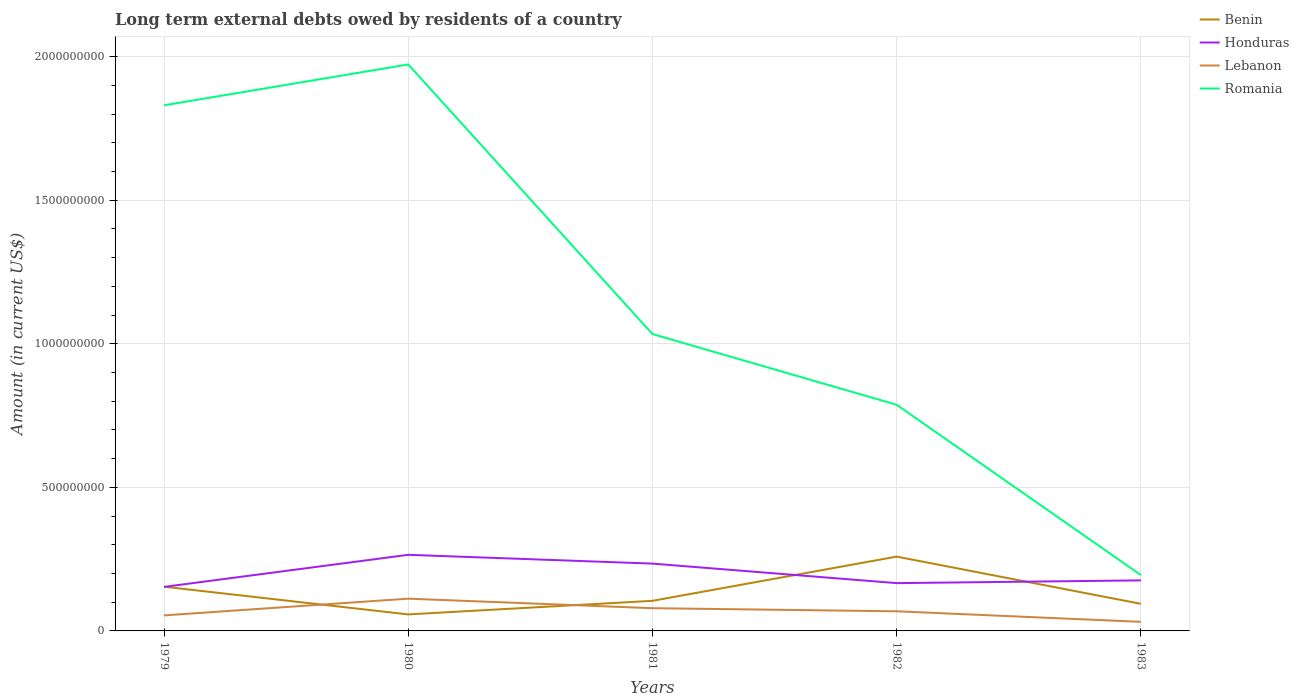How many different coloured lines are there?
Offer a terse response. 4. Across all years, what is the maximum amount of long-term external debts owed by residents in Benin?
Your answer should be very brief. 5.75e+07. In which year was the amount of long-term external debts owed by residents in Romania maximum?
Your response must be concise. 1983. What is the total amount of long-term external debts owed by residents in Honduras in the graph?
Give a very brief answer. -1.31e+07. What is the difference between the highest and the second highest amount of long-term external debts owed by residents in Lebanon?
Give a very brief answer. 8.07e+07. What is the difference between the highest and the lowest amount of long-term external debts owed by residents in Honduras?
Ensure brevity in your answer.  2. Is the amount of long-term external debts owed by residents in Romania strictly greater than the amount of long-term external debts owed by residents in Honduras over the years?
Keep it short and to the point. No. How many years are there in the graph?
Your answer should be compact. 5. Does the graph contain any zero values?
Provide a short and direct response. No. What is the title of the graph?
Ensure brevity in your answer.  Long term external debts owed by residents of a country. What is the label or title of the X-axis?
Give a very brief answer. Years. What is the label or title of the Y-axis?
Provide a succinct answer. Amount (in current US$). What is the Amount (in current US$) of Benin in 1979?
Offer a terse response. 1.54e+08. What is the Amount (in current US$) of Honduras in 1979?
Provide a succinct answer. 1.53e+08. What is the Amount (in current US$) of Lebanon in 1979?
Make the answer very short. 5.41e+07. What is the Amount (in current US$) in Romania in 1979?
Give a very brief answer. 1.83e+09. What is the Amount (in current US$) in Benin in 1980?
Give a very brief answer. 5.75e+07. What is the Amount (in current US$) in Honduras in 1980?
Your answer should be very brief. 2.65e+08. What is the Amount (in current US$) of Lebanon in 1980?
Ensure brevity in your answer.  1.12e+08. What is the Amount (in current US$) of Romania in 1980?
Offer a very short reply. 1.97e+09. What is the Amount (in current US$) in Benin in 1981?
Your answer should be compact. 1.05e+08. What is the Amount (in current US$) of Honduras in 1981?
Offer a very short reply. 2.34e+08. What is the Amount (in current US$) of Lebanon in 1981?
Your answer should be compact. 7.92e+07. What is the Amount (in current US$) in Romania in 1981?
Keep it short and to the point. 1.03e+09. What is the Amount (in current US$) in Benin in 1982?
Give a very brief answer. 2.59e+08. What is the Amount (in current US$) in Honduras in 1982?
Provide a short and direct response. 1.66e+08. What is the Amount (in current US$) in Lebanon in 1982?
Your response must be concise. 6.84e+07. What is the Amount (in current US$) of Romania in 1982?
Keep it short and to the point. 7.88e+08. What is the Amount (in current US$) of Benin in 1983?
Offer a very short reply. 9.44e+07. What is the Amount (in current US$) in Honduras in 1983?
Offer a terse response. 1.76e+08. What is the Amount (in current US$) of Lebanon in 1983?
Offer a terse response. 3.17e+07. What is the Amount (in current US$) of Romania in 1983?
Your answer should be very brief. 1.95e+08. Across all years, what is the maximum Amount (in current US$) of Benin?
Give a very brief answer. 2.59e+08. Across all years, what is the maximum Amount (in current US$) of Honduras?
Keep it short and to the point. 2.65e+08. Across all years, what is the maximum Amount (in current US$) in Lebanon?
Provide a short and direct response. 1.12e+08. Across all years, what is the maximum Amount (in current US$) in Romania?
Give a very brief answer. 1.97e+09. Across all years, what is the minimum Amount (in current US$) in Benin?
Your answer should be very brief. 5.75e+07. Across all years, what is the minimum Amount (in current US$) in Honduras?
Provide a short and direct response. 1.53e+08. Across all years, what is the minimum Amount (in current US$) in Lebanon?
Your answer should be compact. 3.17e+07. Across all years, what is the minimum Amount (in current US$) of Romania?
Offer a very short reply. 1.95e+08. What is the total Amount (in current US$) of Benin in the graph?
Give a very brief answer. 6.70e+08. What is the total Amount (in current US$) of Honduras in the graph?
Provide a short and direct response. 9.95e+08. What is the total Amount (in current US$) in Lebanon in the graph?
Offer a very short reply. 3.46e+08. What is the total Amount (in current US$) in Romania in the graph?
Your answer should be compact. 5.82e+09. What is the difference between the Amount (in current US$) in Benin in 1979 and that in 1980?
Provide a succinct answer. 9.65e+07. What is the difference between the Amount (in current US$) in Honduras in 1979 and that in 1980?
Your response must be concise. -1.12e+08. What is the difference between the Amount (in current US$) in Lebanon in 1979 and that in 1980?
Give a very brief answer. -5.83e+07. What is the difference between the Amount (in current US$) of Romania in 1979 and that in 1980?
Your response must be concise. -1.42e+08. What is the difference between the Amount (in current US$) of Benin in 1979 and that in 1981?
Ensure brevity in your answer.  4.92e+07. What is the difference between the Amount (in current US$) of Honduras in 1979 and that in 1981?
Offer a terse response. -8.11e+07. What is the difference between the Amount (in current US$) of Lebanon in 1979 and that in 1981?
Offer a terse response. -2.51e+07. What is the difference between the Amount (in current US$) in Romania in 1979 and that in 1981?
Your response must be concise. 7.97e+08. What is the difference between the Amount (in current US$) in Benin in 1979 and that in 1982?
Ensure brevity in your answer.  -1.05e+08. What is the difference between the Amount (in current US$) of Honduras in 1979 and that in 1982?
Your answer should be very brief. -1.31e+07. What is the difference between the Amount (in current US$) in Lebanon in 1979 and that in 1982?
Your response must be concise. -1.43e+07. What is the difference between the Amount (in current US$) in Romania in 1979 and that in 1982?
Provide a succinct answer. 1.04e+09. What is the difference between the Amount (in current US$) in Benin in 1979 and that in 1983?
Your answer should be compact. 5.96e+07. What is the difference between the Amount (in current US$) in Honduras in 1979 and that in 1983?
Offer a very short reply. -2.27e+07. What is the difference between the Amount (in current US$) of Lebanon in 1979 and that in 1983?
Ensure brevity in your answer.  2.24e+07. What is the difference between the Amount (in current US$) in Romania in 1979 and that in 1983?
Your answer should be compact. 1.64e+09. What is the difference between the Amount (in current US$) in Benin in 1980 and that in 1981?
Provide a succinct answer. -4.73e+07. What is the difference between the Amount (in current US$) of Honduras in 1980 and that in 1981?
Make the answer very short. 3.06e+07. What is the difference between the Amount (in current US$) of Lebanon in 1980 and that in 1981?
Provide a short and direct response. 3.32e+07. What is the difference between the Amount (in current US$) in Romania in 1980 and that in 1981?
Provide a short and direct response. 9.39e+08. What is the difference between the Amount (in current US$) in Benin in 1980 and that in 1982?
Keep it short and to the point. -2.01e+08. What is the difference between the Amount (in current US$) in Honduras in 1980 and that in 1982?
Offer a very short reply. 9.86e+07. What is the difference between the Amount (in current US$) in Lebanon in 1980 and that in 1982?
Provide a succinct answer. 4.40e+07. What is the difference between the Amount (in current US$) in Romania in 1980 and that in 1982?
Offer a terse response. 1.19e+09. What is the difference between the Amount (in current US$) in Benin in 1980 and that in 1983?
Offer a very short reply. -3.69e+07. What is the difference between the Amount (in current US$) in Honduras in 1980 and that in 1983?
Offer a very short reply. 8.90e+07. What is the difference between the Amount (in current US$) of Lebanon in 1980 and that in 1983?
Ensure brevity in your answer.  8.07e+07. What is the difference between the Amount (in current US$) of Romania in 1980 and that in 1983?
Keep it short and to the point. 1.78e+09. What is the difference between the Amount (in current US$) of Benin in 1981 and that in 1982?
Your response must be concise. -1.54e+08. What is the difference between the Amount (in current US$) of Honduras in 1981 and that in 1982?
Offer a very short reply. 6.80e+07. What is the difference between the Amount (in current US$) in Lebanon in 1981 and that in 1982?
Offer a terse response. 1.08e+07. What is the difference between the Amount (in current US$) of Romania in 1981 and that in 1982?
Make the answer very short. 2.46e+08. What is the difference between the Amount (in current US$) in Benin in 1981 and that in 1983?
Make the answer very short. 1.04e+07. What is the difference between the Amount (in current US$) of Honduras in 1981 and that in 1983?
Ensure brevity in your answer.  5.84e+07. What is the difference between the Amount (in current US$) in Lebanon in 1981 and that in 1983?
Make the answer very short. 4.75e+07. What is the difference between the Amount (in current US$) of Romania in 1981 and that in 1983?
Your answer should be very brief. 8.39e+08. What is the difference between the Amount (in current US$) in Benin in 1982 and that in 1983?
Your answer should be very brief. 1.64e+08. What is the difference between the Amount (in current US$) in Honduras in 1982 and that in 1983?
Provide a short and direct response. -9.57e+06. What is the difference between the Amount (in current US$) in Lebanon in 1982 and that in 1983?
Your answer should be very brief. 3.67e+07. What is the difference between the Amount (in current US$) in Romania in 1982 and that in 1983?
Provide a short and direct response. 5.93e+08. What is the difference between the Amount (in current US$) in Benin in 1979 and the Amount (in current US$) in Honduras in 1980?
Provide a short and direct response. -1.11e+08. What is the difference between the Amount (in current US$) of Benin in 1979 and the Amount (in current US$) of Lebanon in 1980?
Your answer should be very brief. 4.16e+07. What is the difference between the Amount (in current US$) in Benin in 1979 and the Amount (in current US$) in Romania in 1980?
Provide a short and direct response. -1.82e+09. What is the difference between the Amount (in current US$) in Honduras in 1979 and the Amount (in current US$) in Lebanon in 1980?
Offer a terse response. 4.10e+07. What is the difference between the Amount (in current US$) in Honduras in 1979 and the Amount (in current US$) in Romania in 1980?
Make the answer very short. -1.82e+09. What is the difference between the Amount (in current US$) of Lebanon in 1979 and the Amount (in current US$) of Romania in 1980?
Your response must be concise. -1.92e+09. What is the difference between the Amount (in current US$) in Benin in 1979 and the Amount (in current US$) in Honduras in 1981?
Offer a terse response. -8.04e+07. What is the difference between the Amount (in current US$) in Benin in 1979 and the Amount (in current US$) in Lebanon in 1981?
Your response must be concise. 7.49e+07. What is the difference between the Amount (in current US$) of Benin in 1979 and the Amount (in current US$) of Romania in 1981?
Keep it short and to the point. -8.80e+08. What is the difference between the Amount (in current US$) in Honduras in 1979 and the Amount (in current US$) in Lebanon in 1981?
Your answer should be compact. 7.42e+07. What is the difference between the Amount (in current US$) of Honduras in 1979 and the Amount (in current US$) of Romania in 1981?
Make the answer very short. -8.81e+08. What is the difference between the Amount (in current US$) in Lebanon in 1979 and the Amount (in current US$) in Romania in 1981?
Ensure brevity in your answer.  -9.80e+08. What is the difference between the Amount (in current US$) in Benin in 1979 and the Amount (in current US$) in Honduras in 1982?
Offer a terse response. -1.25e+07. What is the difference between the Amount (in current US$) in Benin in 1979 and the Amount (in current US$) in Lebanon in 1982?
Ensure brevity in your answer.  8.56e+07. What is the difference between the Amount (in current US$) in Benin in 1979 and the Amount (in current US$) in Romania in 1982?
Offer a terse response. -6.34e+08. What is the difference between the Amount (in current US$) of Honduras in 1979 and the Amount (in current US$) of Lebanon in 1982?
Ensure brevity in your answer.  8.50e+07. What is the difference between the Amount (in current US$) of Honduras in 1979 and the Amount (in current US$) of Romania in 1982?
Make the answer very short. -6.34e+08. What is the difference between the Amount (in current US$) of Lebanon in 1979 and the Amount (in current US$) of Romania in 1982?
Give a very brief answer. -7.34e+08. What is the difference between the Amount (in current US$) of Benin in 1979 and the Amount (in current US$) of Honduras in 1983?
Provide a succinct answer. -2.20e+07. What is the difference between the Amount (in current US$) of Benin in 1979 and the Amount (in current US$) of Lebanon in 1983?
Make the answer very short. 1.22e+08. What is the difference between the Amount (in current US$) of Benin in 1979 and the Amount (in current US$) of Romania in 1983?
Offer a very short reply. -4.06e+07. What is the difference between the Amount (in current US$) in Honduras in 1979 and the Amount (in current US$) in Lebanon in 1983?
Your answer should be compact. 1.22e+08. What is the difference between the Amount (in current US$) in Honduras in 1979 and the Amount (in current US$) in Romania in 1983?
Offer a very short reply. -4.12e+07. What is the difference between the Amount (in current US$) in Lebanon in 1979 and the Amount (in current US$) in Romania in 1983?
Keep it short and to the point. -1.40e+08. What is the difference between the Amount (in current US$) in Benin in 1980 and the Amount (in current US$) in Honduras in 1981?
Keep it short and to the point. -1.77e+08. What is the difference between the Amount (in current US$) of Benin in 1980 and the Amount (in current US$) of Lebanon in 1981?
Offer a terse response. -2.17e+07. What is the difference between the Amount (in current US$) in Benin in 1980 and the Amount (in current US$) in Romania in 1981?
Give a very brief answer. -9.76e+08. What is the difference between the Amount (in current US$) of Honduras in 1980 and the Amount (in current US$) of Lebanon in 1981?
Make the answer very short. 1.86e+08. What is the difference between the Amount (in current US$) of Honduras in 1980 and the Amount (in current US$) of Romania in 1981?
Your response must be concise. -7.69e+08. What is the difference between the Amount (in current US$) of Lebanon in 1980 and the Amount (in current US$) of Romania in 1981?
Your response must be concise. -9.22e+08. What is the difference between the Amount (in current US$) of Benin in 1980 and the Amount (in current US$) of Honduras in 1982?
Offer a very short reply. -1.09e+08. What is the difference between the Amount (in current US$) in Benin in 1980 and the Amount (in current US$) in Lebanon in 1982?
Provide a succinct answer. -1.09e+07. What is the difference between the Amount (in current US$) of Benin in 1980 and the Amount (in current US$) of Romania in 1982?
Offer a terse response. -7.30e+08. What is the difference between the Amount (in current US$) in Honduras in 1980 and the Amount (in current US$) in Lebanon in 1982?
Make the answer very short. 1.97e+08. What is the difference between the Amount (in current US$) in Honduras in 1980 and the Amount (in current US$) in Romania in 1982?
Provide a short and direct response. -5.23e+08. What is the difference between the Amount (in current US$) in Lebanon in 1980 and the Amount (in current US$) in Romania in 1982?
Your response must be concise. -6.75e+08. What is the difference between the Amount (in current US$) in Benin in 1980 and the Amount (in current US$) in Honduras in 1983?
Keep it short and to the point. -1.19e+08. What is the difference between the Amount (in current US$) of Benin in 1980 and the Amount (in current US$) of Lebanon in 1983?
Offer a terse response. 2.58e+07. What is the difference between the Amount (in current US$) of Benin in 1980 and the Amount (in current US$) of Romania in 1983?
Give a very brief answer. -1.37e+08. What is the difference between the Amount (in current US$) in Honduras in 1980 and the Amount (in current US$) in Lebanon in 1983?
Your answer should be compact. 2.33e+08. What is the difference between the Amount (in current US$) of Honduras in 1980 and the Amount (in current US$) of Romania in 1983?
Provide a succinct answer. 7.05e+07. What is the difference between the Amount (in current US$) in Lebanon in 1980 and the Amount (in current US$) in Romania in 1983?
Provide a succinct answer. -8.22e+07. What is the difference between the Amount (in current US$) of Benin in 1981 and the Amount (in current US$) of Honduras in 1982?
Offer a terse response. -6.17e+07. What is the difference between the Amount (in current US$) in Benin in 1981 and the Amount (in current US$) in Lebanon in 1982?
Your answer should be very brief. 3.64e+07. What is the difference between the Amount (in current US$) in Benin in 1981 and the Amount (in current US$) in Romania in 1982?
Ensure brevity in your answer.  -6.83e+08. What is the difference between the Amount (in current US$) in Honduras in 1981 and the Amount (in current US$) in Lebanon in 1982?
Provide a succinct answer. 1.66e+08. What is the difference between the Amount (in current US$) of Honduras in 1981 and the Amount (in current US$) of Romania in 1982?
Offer a very short reply. -5.53e+08. What is the difference between the Amount (in current US$) of Lebanon in 1981 and the Amount (in current US$) of Romania in 1982?
Your response must be concise. -7.08e+08. What is the difference between the Amount (in current US$) in Benin in 1981 and the Amount (in current US$) in Honduras in 1983?
Your answer should be compact. -7.12e+07. What is the difference between the Amount (in current US$) of Benin in 1981 and the Amount (in current US$) of Lebanon in 1983?
Your answer should be very brief. 7.31e+07. What is the difference between the Amount (in current US$) in Benin in 1981 and the Amount (in current US$) in Romania in 1983?
Offer a very short reply. -8.98e+07. What is the difference between the Amount (in current US$) of Honduras in 1981 and the Amount (in current US$) of Lebanon in 1983?
Make the answer very short. 2.03e+08. What is the difference between the Amount (in current US$) in Honduras in 1981 and the Amount (in current US$) in Romania in 1983?
Make the answer very short. 3.99e+07. What is the difference between the Amount (in current US$) of Lebanon in 1981 and the Amount (in current US$) of Romania in 1983?
Ensure brevity in your answer.  -1.15e+08. What is the difference between the Amount (in current US$) of Benin in 1982 and the Amount (in current US$) of Honduras in 1983?
Offer a very short reply. 8.28e+07. What is the difference between the Amount (in current US$) of Benin in 1982 and the Amount (in current US$) of Lebanon in 1983?
Offer a very short reply. 2.27e+08. What is the difference between the Amount (in current US$) in Benin in 1982 and the Amount (in current US$) in Romania in 1983?
Make the answer very short. 6.42e+07. What is the difference between the Amount (in current US$) in Honduras in 1982 and the Amount (in current US$) in Lebanon in 1983?
Keep it short and to the point. 1.35e+08. What is the difference between the Amount (in current US$) of Honduras in 1982 and the Amount (in current US$) of Romania in 1983?
Ensure brevity in your answer.  -2.81e+07. What is the difference between the Amount (in current US$) of Lebanon in 1982 and the Amount (in current US$) of Romania in 1983?
Ensure brevity in your answer.  -1.26e+08. What is the average Amount (in current US$) of Benin per year?
Provide a succinct answer. 1.34e+08. What is the average Amount (in current US$) in Honduras per year?
Offer a very short reply. 1.99e+08. What is the average Amount (in current US$) in Lebanon per year?
Ensure brevity in your answer.  6.91e+07. What is the average Amount (in current US$) in Romania per year?
Ensure brevity in your answer.  1.16e+09. In the year 1979, what is the difference between the Amount (in current US$) in Benin and Amount (in current US$) in Honduras?
Give a very brief answer. 6.81e+05. In the year 1979, what is the difference between the Amount (in current US$) of Benin and Amount (in current US$) of Lebanon?
Your answer should be compact. 9.99e+07. In the year 1979, what is the difference between the Amount (in current US$) of Benin and Amount (in current US$) of Romania?
Your answer should be very brief. -1.68e+09. In the year 1979, what is the difference between the Amount (in current US$) of Honduras and Amount (in current US$) of Lebanon?
Provide a succinct answer. 9.92e+07. In the year 1979, what is the difference between the Amount (in current US$) of Honduras and Amount (in current US$) of Romania?
Your answer should be very brief. -1.68e+09. In the year 1979, what is the difference between the Amount (in current US$) of Lebanon and Amount (in current US$) of Romania?
Give a very brief answer. -1.78e+09. In the year 1980, what is the difference between the Amount (in current US$) of Benin and Amount (in current US$) of Honduras?
Ensure brevity in your answer.  -2.08e+08. In the year 1980, what is the difference between the Amount (in current US$) of Benin and Amount (in current US$) of Lebanon?
Give a very brief answer. -5.49e+07. In the year 1980, what is the difference between the Amount (in current US$) in Benin and Amount (in current US$) in Romania?
Your answer should be very brief. -1.92e+09. In the year 1980, what is the difference between the Amount (in current US$) in Honduras and Amount (in current US$) in Lebanon?
Make the answer very short. 1.53e+08. In the year 1980, what is the difference between the Amount (in current US$) of Honduras and Amount (in current US$) of Romania?
Make the answer very short. -1.71e+09. In the year 1980, what is the difference between the Amount (in current US$) of Lebanon and Amount (in current US$) of Romania?
Give a very brief answer. -1.86e+09. In the year 1981, what is the difference between the Amount (in current US$) in Benin and Amount (in current US$) in Honduras?
Keep it short and to the point. -1.30e+08. In the year 1981, what is the difference between the Amount (in current US$) in Benin and Amount (in current US$) in Lebanon?
Your answer should be very brief. 2.56e+07. In the year 1981, what is the difference between the Amount (in current US$) in Benin and Amount (in current US$) in Romania?
Offer a very short reply. -9.29e+08. In the year 1981, what is the difference between the Amount (in current US$) in Honduras and Amount (in current US$) in Lebanon?
Give a very brief answer. 1.55e+08. In the year 1981, what is the difference between the Amount (in current US$) in Honduras and Amount (in current US$) in Romania?
Your answer should be compact. -7.99e+08. In the year 1981, what is the difference between the Amount (in current US$) of Lebanon and Amount (in current US$) of Romania?
Offer a terse response. -9.55e+08. In the year 1982, what is the difference between the Amount (in current US$) of Benin and Amount (in current US$) of Honduras?
Make the answer very short. 9.23e+07. In the year 1982, what is the difference between the Amount (in current US$) in Benin and Amount (in current US$) in Lebanon?
Provide a succinct answer. 1.90e+08. In the year 1982, what is the difference between the Amount (in current US$) in Benin and Amount (in current US$) in Romania?
Offer a very short reply. -5.29e+08. In the year 1982, what is the difference between the Amount (in current US$) in Honduras and Amount (in current US$) in Lebanon?
Offer a very short reply. 9.81e+07. In the year 1982, what is the difference between the Amount (in current US$) of Honduras and Amount (in current US$) of Romania?
Provide a short and direct response. -6.21e+08. In the year 1982, what is the difference between the Amount (in current US$) of Lebanon and Amount (in current US$) of Romania?
Your answer should be compact. -7.19e+08. In the year 1983, what is the difference between the Amount (in current US$) of Benin and Amount (in current US$) of Honduras?
Your response must be concise. -8.16e+07. In the year 1983, what is the difference between the Amount (in current US$) of Benin and Amount (in current US$) of Lebanon?
Provide a succinct answer. 6.27e+07. In the year 1983, what is the difference between the Amount (in current US$) of Benin and Amount (in current US$) of Romania?
Offer a terse response. -1.00e+08. In the year 1983, what is the difference between the Amount (in current US$) in Honduras and Amount (in current US$) in Lebanon?
Your answer should be very brief. 1.44e+08. In the year 1983, what is the difference between the Amount (in current US$) of Honduras and Amount (in current US$) of Romania?
Give a very brief answer. -1.85e+07. In the year 1983, what is the difference between the Amount (in current US$) in Lebanon and Amount (in current US$) in Romania?
Your answer should be compact. -1.63e+08. What is the ratio of the Amount (in current US$) of Benin in 1979 to that in 1980?
Offer a terse response. 2.68. What is the ratio of the Amount (in current US$) in Honduras in 1979 to that in 1980?
Ensure brevity in your answer.  0.58. What is the ratio of the Amount (in current US$) in Lebanon in 1979 to that in 1980?
Provide a succinct answer. 0.48. What is the ratio of the Amount (in current US$) in Romania in 1979 to that in 1980?
Make the answer very short. 0.93. What is the ratio of the Amount (in current US$) in Benin in 1979 to that in 1981?
Provide a succinct answer. 1.47. What is the ratio of the Amount (in current US$) in Honduras in 1979 to that in 1981?
Make the answer very short. 0.65. What is the ratio of the Amount (in current US$) in Lebanon in 1979 to that in 1981?
Your answer should be compact. 0.68. What is the ratio of the Amount (in current US$) in Romania in 1979 to that in 1981?
Provide a short and direct response. 1.77. What is the ratio of the Amount (in current US$) in Benin in 1979 to that in 1982?
Offer a terse response. 0.6. What is the ratio of the Amount (in current US$) of Honduras in 1979 to that in 1982?
Provide a short and direct response. 0.92. What is the ratio of the Amount (in current US$) in Lebanon in 1979 to that in 1982?
Your answer should be very brief. 0.79. What is the ratio of the Amount (in current US$) of Romania in 1979 to that in 1982?
Make the answer very short. 2.32. What is the ratio of the Amount (in current US$) in Benin in 1979 to that in 1983?
Ensure brevity in your answer.  1.63. What is the ratio of the Amount (in current US$) in Honduras in 1979 to that in 1983?
Make the answer very short. 0.87. What is the ratio of the Amount (in current US$) of Lebanon in 1979 to that in 1983?
Your response must be concise. 1.71. What is the ratio of the Amount (in current US$) of Romania in 1979 to that in 1983?
Your response must be concise. 9.41. What is the ratio of the Amount (in current US$) of Benin in 1980 to that in 1981?
Ensure brevity in your answer.  0.55. What is the ratio of the Amount (in current US$) of Honduras in 1980 to that in 1981?
Give a very brief answer. 1.13. What is the ratio of the Amount (in current US$) in Lebanon in 1980 to that in 1981?
Your response must be concise. 1.42. What is the ratio of the Amount (in current US$) in Romania in 1980 to that in 1981?
Give a very brief answer. 1.91. What is the ratio of the Amount (in current US$) in Benin in 1980 to that in 1982?
Your answer should be compact. 0.22. What is the ratio of the Amount (in current US$) of Honduras in 1980 to that in 1982?
Your answer should be very brief. 1.59. What is the ratio of the Amount (in current US$) of Lebanon in 1980 to that in 1982?
Ensure brevity in your answer.  1.64. What is the ratio of the Amount (in current US$) in Romania in 1980 to that in 1982?
Make the answer very short. 2.5. What is the ratio of the Amount (in current US$) of Benin in 1980 to that in 1983?
Make the answer very short. 0.61. What is the ratio of the Amount (in current US$) of Honduras in 1980 to that in 1983?
Make the answer very short. 1.51. What is the ratio of the Amount (in current US$) in Lebanon in 1980 to that in 1983?
Offer a very short reply. 3.55. What is the ratio of the Amount (in current US$) in Romania in 1980 to that in 1983?
Your answer should be very brief. 10.14. What is the ratio of the Amount (in current US$) in Benin in 1981 to that in 1982?
Offer a terse response. 0.4. What is the ratio of the Amount (in current US$) of Honduras in 1981 to that in 1982?
Provide a succinct answer. 1.41. What is the ratio of the Amount (in current US$) in Lebanon in 1981 to that in 1982?
Offer a very short reply. 1.16. What is the ratio of the Amount (in current US$) in Romania in 1981 to that in 1982?
Keep it short and to the point. 1.31. What is the ratio of the Amount (in current US$) of Benin in 1981 to that in 1983?
Provide a succinct answer. 1.11. What is the ratio of the Amount (in current US$) in Honduras in 1981 to that in 1983?
Provide a succinct answer. 1.33. What is the ratio of the Amount (in current US$) of Lebanon in 1981 to that in 1983?
Your response must be concise. 2.5. What is the ratio of the Amount (in current US$) in Romania in 1981 to that in 1983?
Provide a succinct answer. 5.31. What is the ratio of the Amount (in current US$) in Benin in 1982 to that in 1983?
Offer a very short reply. 2.74. What is the ratio of the Amount (in current US$) of Honduras in 1982 to that in 1983?
Your answer should be very brief. 0.95. What is the ratio of the Amount (in current US$) in Lebanon in 1982 to that in 1983?
Give a very brief answer. 2.16. What is the ratio of the Amount (in current US$) in Romania in 1982 to that in 1983?
Keep it short and to the point. 4.05. What is the difference between the highest and the second highest Amount (in current US$) in Benin?
Your response must be concise. 1.05e+08. What is the difference between the highest and the second highest Amount (in current US$) in Honduras?
Ensure brevity in your answer.  3.06e+07. What is the difference between the highest and the second highest Amount (in current US$) of Lebanon?
Keep it short and to the point. 3.32e+07. What is the difference between the highest and the second highest Amount (in current US$) in Romania?
Keep it short and to the point. 1.42e+08. What is the difference between the highest and the lowest Amount (in current US$) of Benin?
Your answer should be very brief. 2.01e+08. What is the difference between the highest and the lowest Amount (in current US$) of Honduras?
Provide a short and direct response. 1.12e+08. What is the difference between the highest and the lowest Amount (in current US$) in Lebanon?
Your response must be concise. 8.07e+07. What is the difference between the highest and the lowest Amount (in current US$) of Romania?
Your response must be concise. 1.78e+09. 